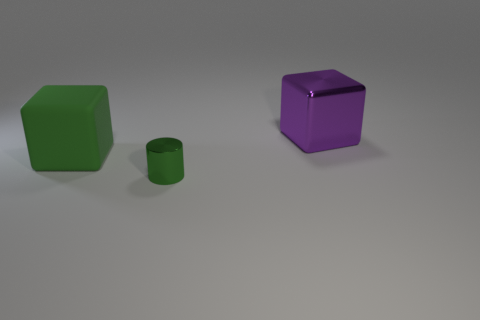Is there a purple shiny block?
Provide a short and direct response. Yes. How many tiny things are shiny cylinders or blue shiny cylinders?
Keep it short and to the point. 1. Are there more cubes that are on the left side of the shiny block than small green metal objects behind the tiny green shiny cylinder?
Keep it short and to the point. Yes. Do the large green thing and the big object that is right of the green cylinder have the same material?
Your answer should be compact. No. The rubber object has what color?
Ensure brevity in your answer.  Green. What shape is the metal object on the right side of the tiny green shiny thing?
Offer a very short reply. Cube. How many purple objects are shiny blocks or cubes?
Provide a succinct answer. 1. The cube that is made of the same material as the green cylinder is what color?
Keep it short and to the point. Purple. Is the color of the cylinder the same as the big matte block that is behind the green cylinder?
Your response must be concise. Yes. There is a thing that is right of the large green rubber block and to the left of the shiny cube; what is its color?
Make the answer very short. Green. 